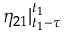<formula> <loc_0><loc_0><loc_500><loc_500>\eta _ { 2 1 } | _ { t _ { 1 } - \tau } ^ { t _ { 1 } }</formula> 